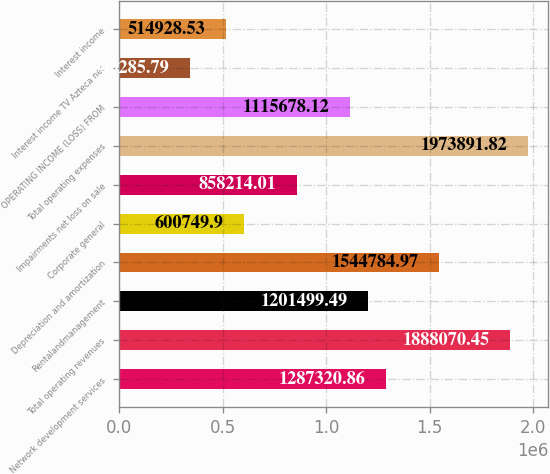Convert chart. <chart><loc_0><loc_0><loc_500><loc_500><bar_chart><fcel>Network development services<fcel>Total operating revenues<fcel>Rentalandmanagement<fcel>Depreciation and amortization<fcel>Corporate general<fcel>Impairments net loss on sale<fcel>Total operating expenses<fcel>OPERATING INCOME (LOSS) FROM<fcel>Interest income TV Azteca net<fcel>Interest income<nl><fcel>1.28732e+06<fcel>1.88807e+06<fcel>1.2015e+06<fcel>1.54478e+06<fcel>600750<fcel>858214<fcel>1.97389e+06<fcel>1.11568e+06<fcel>343286<fcel>514929<nl></chart> 